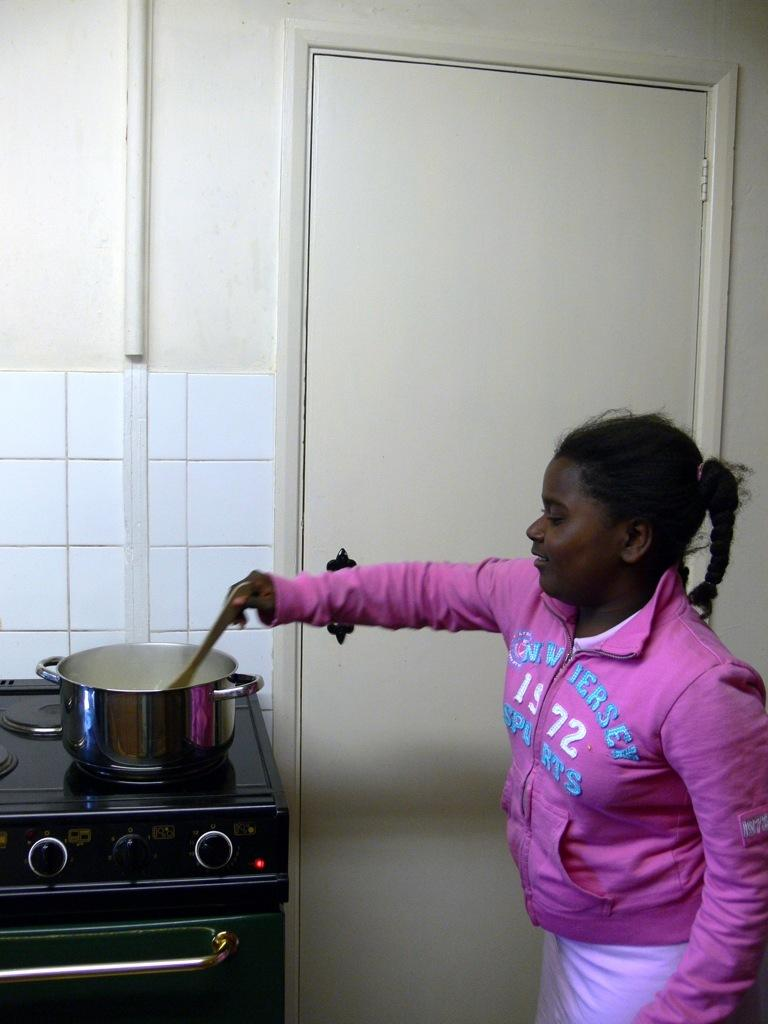<image>
Give a short and clear explanation of the subsequent image. A black woman wearing a pink sweatshirt with 1972 on it stirs the boiling pot. 